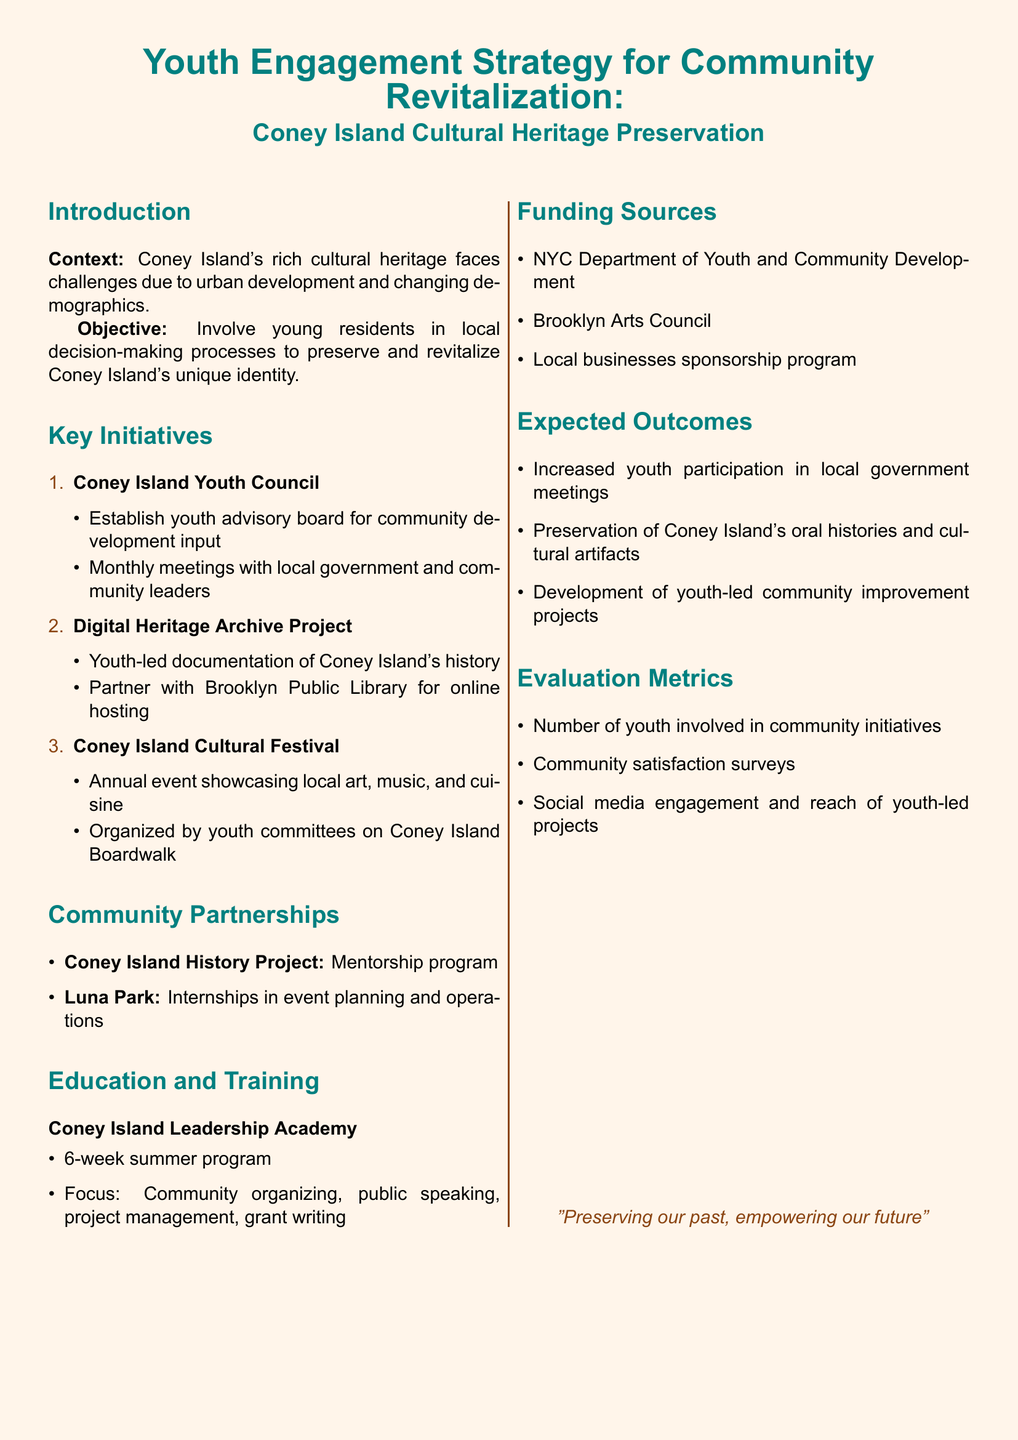What is the main objective of the Youth Engagement Strategy? The objective is to involve young residents in local decision-making processes to preserve and revitalize Coney Island's unique identity.
Answer: Involve young residents in local decision-making processes How many key initiatives are listed in the document? The document lists three key initiatives for youth engagement.
Answer: Three What is the name of the youth advisory board mentioned? The advisory board established for community development input is called the Coney Island Youth Council.
Answer: Coney Island Youth Council What type of program is the Coney Island Leadership Academy? It is a summer program focused on various skills pertinent to community engagement and organizing.
Answer: Summer program Which organization is partnering for the Digital Heritage Archive Project? The Digital Heritage Archive Project partners with the Brooklyn Public Library for online hosting.
Answer: Brooklyn Public Library How often does the Coney Island Youth Council meet? The Coney Island Youth Council meets monthly with local government and community leaders.
Answer: Monthly What is one expected outcome of the youth engagement initiative? One expected outcome is the preservation of Coney Island's oral histories and cultural artifacts.
Answer: Preservation of Coney Island's oral histories and cultural artifacts Which funding source is mentioned for community initiatives? The NYC Department of Youth and Community Development is one of the funding sources mentioned.
Answer: NYC Department of Youth and Community Development What does the Coney Island Cultural Festival showcase? The Coney Island Cultural Festival showcases local art, music, and cuisine.
Answer: Local art, music, and cuisine 